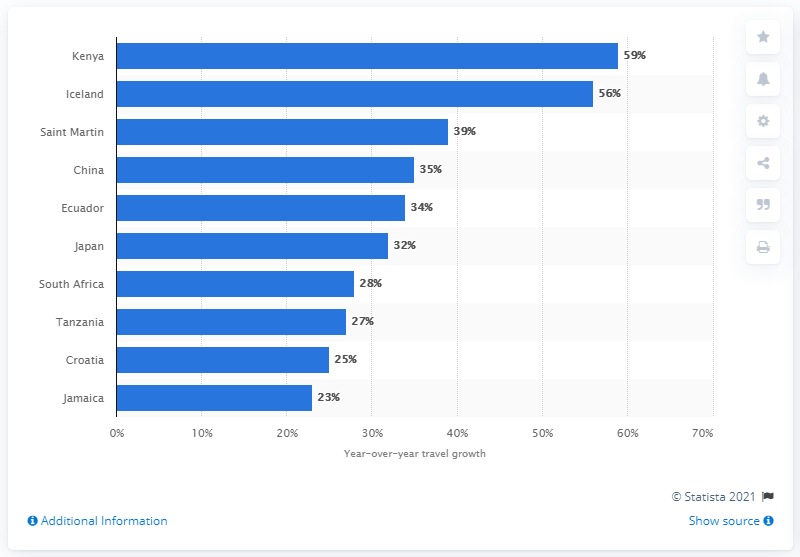Give some essential details in this illustration. Luxury travel to Kenya increased by 59% in 2016 compared to the previous year, according to recent data. 